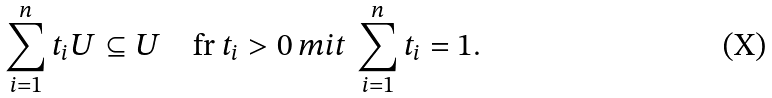Convert formula to latex. <formula><loc_0><loc_0><loc_500><loc_500>\sum _ { i = 1 } ^ { n } t _ { i } U \subseteq U \quad \text {fr } t _ { i } > 0 \, m i t \, \sum _ { i = 1 } ^ { n } t _ { i } = 1 .</formula> 